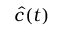Convert formula to latex. <formula><loc_0><loc_0><loc_500><loc_500>\widehat { c } ( t )</formula> 